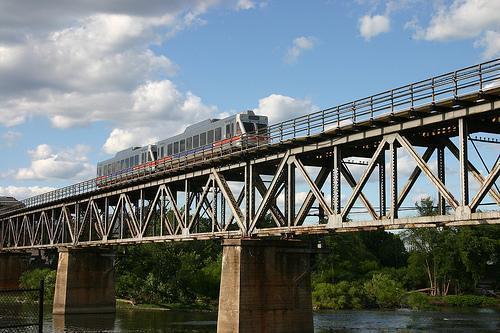How many trains are in the picture?
Give a very brief answer. 1. 